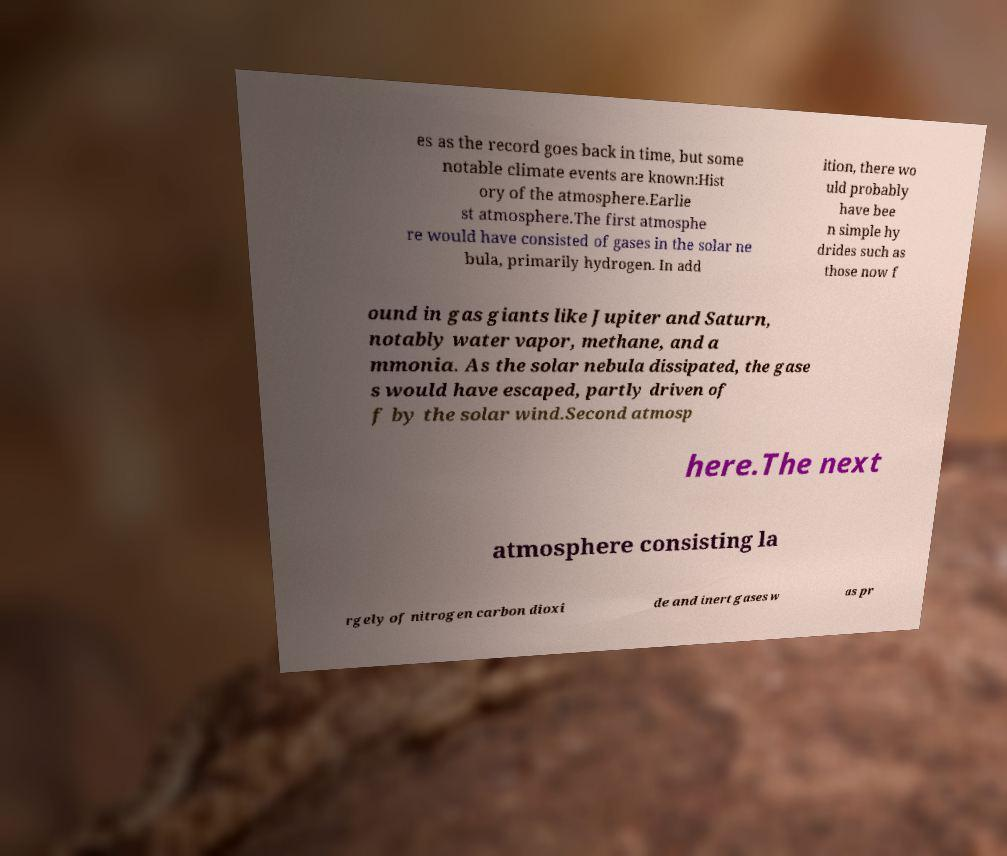What messages or text are displayed in this image? I need them in a readable, typed format. es as the record goes back in time, but some notable climate events are known:Hist ory of the atmosphere.Earlie st atmosphere.The first atmosphe re would have consisted of gases in the solar ne bula, primarily hydrogen. In add ition, there wo uld probably have bee n simple hy drides such as those now f ound in gas giants like Jupiter and Saturn, notably water vapor, methane, and a mmonia. As the solar nebula dissipated, the gase s would have escaped, partly driven of f by the solar wind.Second atmosp here.The next atmosphere consisting la rgely of nitrogen carbon dioxi de and inert gases w as pr 